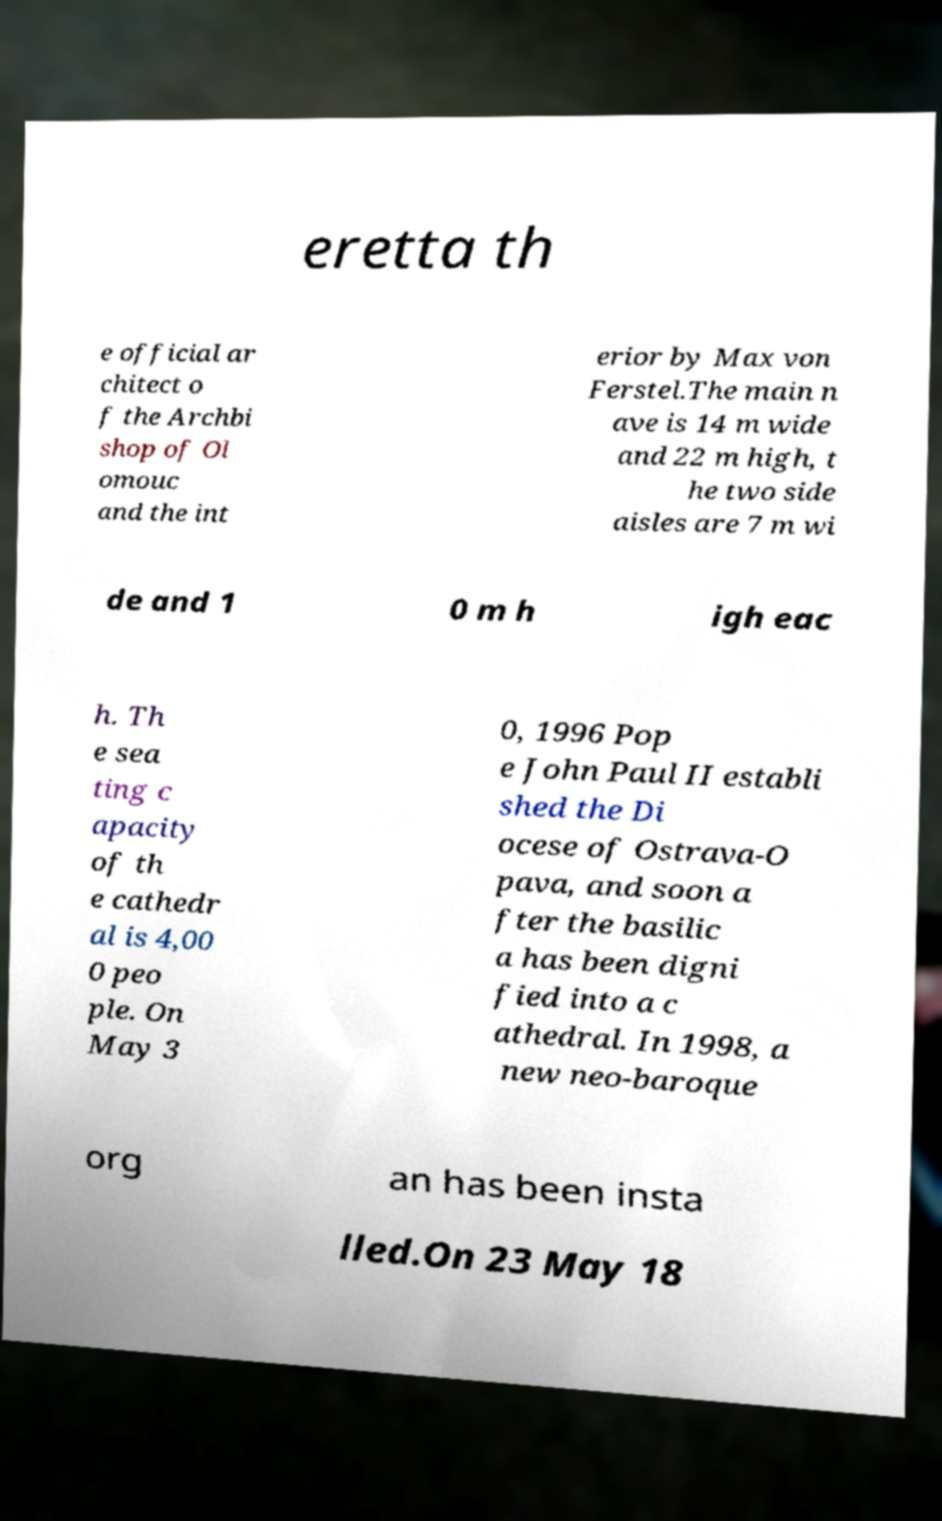Please identify and transcribe the text found in this image. eretta th e official ar chitect o f the Archbi shop of Ol omouc and the int erior by Max von Ferstel.The main n ave is 14 m wide and 22 m high, t he two side aisles are 7 m wi de and 1 0 m h igh eac h. Th e sea ting c apacity of th e cathedr al is 4,00 0 peo ple. On May 3 0, 1996 Pop e John Paul II establi shed the Di ocese of Ostrava-O pava, and soon a fter the basilic a has been digni fied into a c athedral. In 1998, a new neo-baroque org an has been insta lled.On 23 May 18 